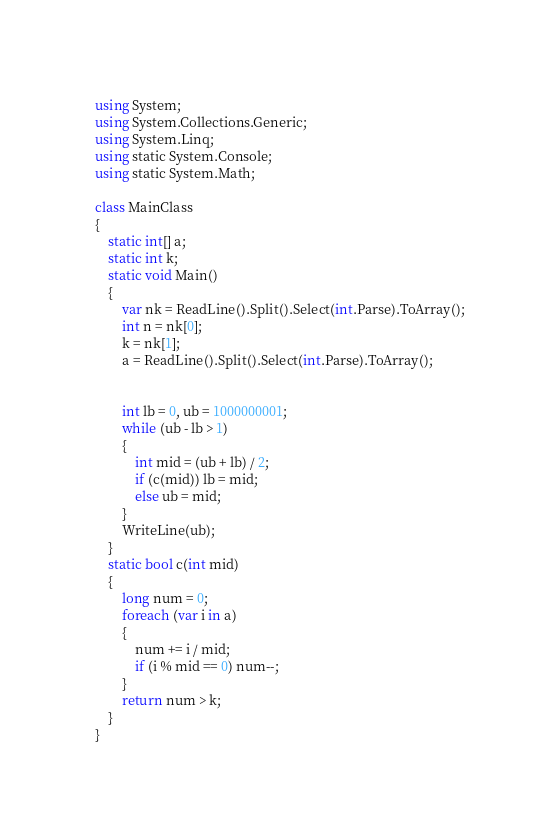Convert code to text. <code><loc_0><loc_0><loc_500><loc_500><_C#_>using System;
using System.Collections.Generic;
using System.Linq;
using static System.Console;
using static System.Math;

class MainClass
{
    static int[] a;
    static int k;
    static void Main()
    {
        var nk = ReadLine().Split().Select(int.Parse).ToArray();
        int n = nk[0];
        k = nk[1];
        a = ReadLine().Split().Select(int.Parse).ToArray();


        int lb = 0, ub = 1000000001;
        while (ub - lb > 1)
        {
            int mid = (ub + lb) / 2;
            if (c(mid)) lb = mid;
            else ub = mid;
        }
        WriteLine(ub);
    }
    static bool c(int mid)
    {
        long num = 0;
        foreach (var i in a)
        {
            num += i / mid;
            if (i % mid == 0) num--;
        }
        return num > k;
    }
}
</code> 